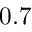<formula> <loc_0><loc_0><loc_500><loc_500>0 . 7</formula> 